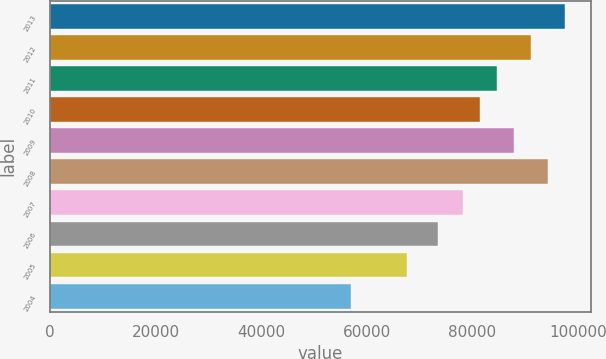Convert chart to OTSL. <chart><loc_0><loc_0><loc_500><loc_500><bar_chart><fcel>2013<fcel>2012<fcel>2011<fcel>2010<fcel>2009<fcel>2008<fcel>2007<fcel>2006<fcel>2005<fcel>2004<nl><fcel>97578.6<fcel>91168.4<fcel>84758.2<fcel>81553.1<fcel>87963.3<fcel>94373.5<fcel>78348<fcel>73493<fcel>67737<fcel>57042<nl></chart> 